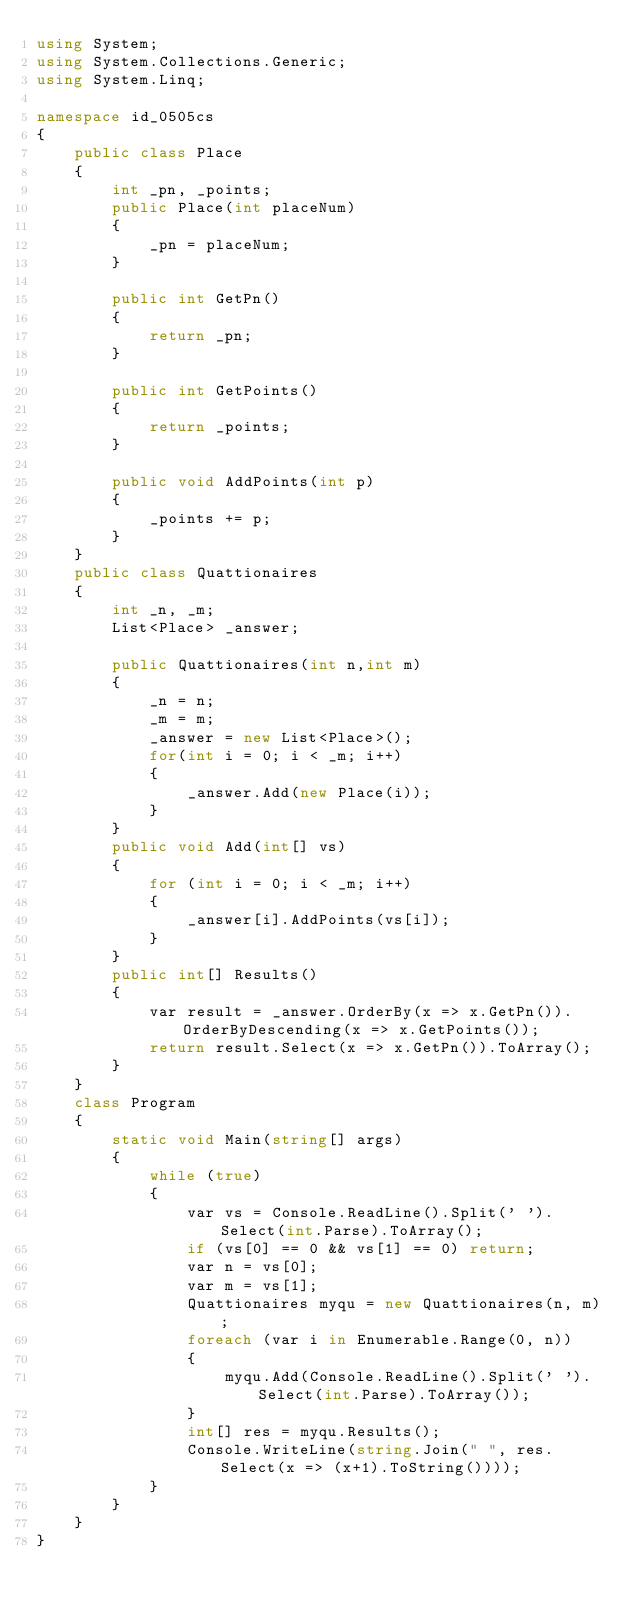Convert code to text. <code><loc_0><loc_0><loc_500><loc_500><_C#_>using System;
using System.Collections.Generic;
using System.Linq;

namespace id_0505cs
{
    public class Place
    {
        int _pn, _points;
        public Place(int placeNum)
        {
            _pn = placeNum;
        }

        public int GetPn()
        {
            return _pn;
        }

        public int GetPoints()
        {
            return _points;
        }

        public void AddPoints(int p)
        {
            _points += p;
        }
    }
    public class Quattionaires
    {
        int _n, _m;
        List<Place> _answer;

        public Quattionaires(int n,int m)
        {
            _n = n;
            _m = m;
            _answer = new List<Place>();
            for(int i = 0; i < _m; i++)
            {
                _answer.Add(new Place(i));
            }
        }
        public void Add(int[] vs)
        {
            for (int i = 0; i < _m; i++)
            {
                _answer[i].AddPoints(vs[i]);
            }
        }
        public int[] Results()
        {
            var result = _answer.OrderBy(x => x.GetPn()).OrderByDescending(x => x.GetPoints());
            return result.Select(x => x.GetPn()).ToArray();
        }
    }
    class Program
    {
        static void Main(string[] args)
        {
            while (true)
            {
                var vs = Console.ReadLine().Split(' ').Select(int.Parse).ToArray();
                if (vs[0] == 0 && vs[1] == 0) return;
                var n = vs[0];
                var m = vs[1];
                Quattionaires myqu = new Quattionaires(n, m);
                foreach (var i in Enumerable.Range(0, n))
                {
                    myqu.Add(Console.ReadLine().Split(' ').Select(int.Parse).ToArray());
                }
                int[] res = myqu.Results();
                Console.WriteLine(string.Join(" ", res.Select(x => (x+1).ToString())));
            }
        }
    }
}

</code> 